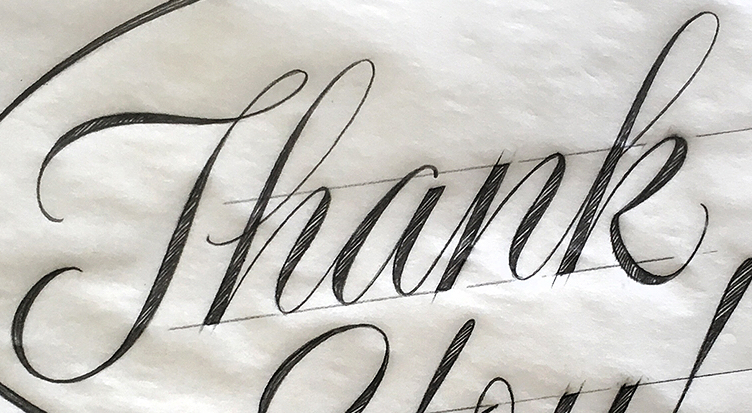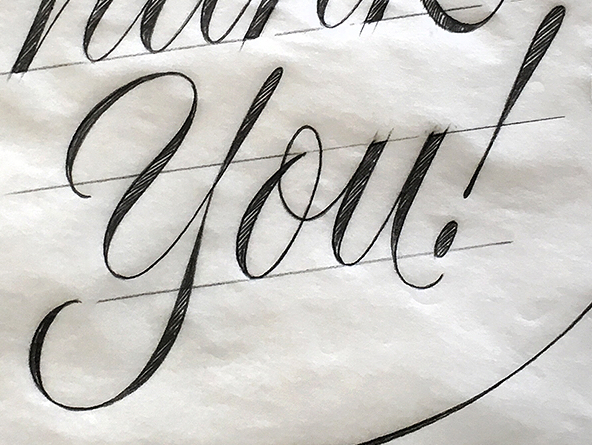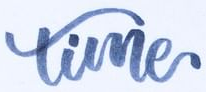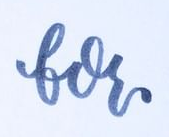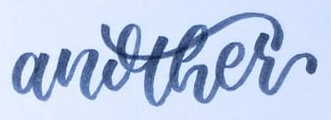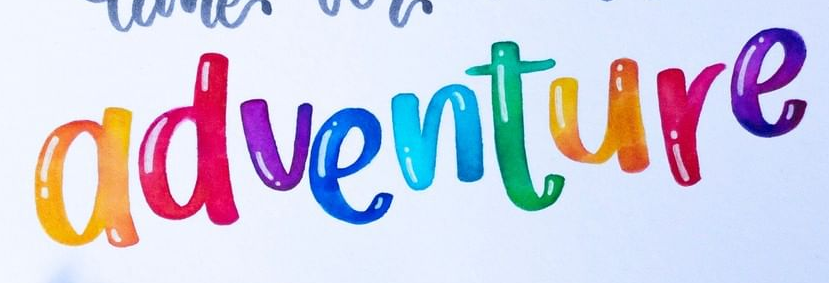What text appears in these images from left to right, separated by a semicolon? Thank; you!; time; for; another; adventure 